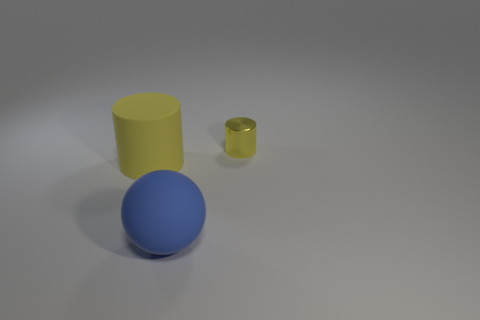Is there any other thing that is the same material as the tiny object?
Give a very brief answer. No. Are there any other things that are the same size as the yellow metal object?
Provide a short and direct response. No. Is the material of the ball the same as the tiny yellow cylinder?
Make the answer very short. No. What shape is the yellow object that is the same size as the blue rubber thing?
Keep it short and to the point. Cylinder. Is the number of small objects greater than the number of big things?
Keep it short and to the point. No. What material is the thing that is on the right side of the large yellow matte cylinder and behind the blue ball?
Your answer should be compact. Metal. What number of other things are made of the same material as the sphere?
Keep it short and to the point. 1. What number of big things have the same color as the sphere?
Your response must be concise. 0. There is a thing on the right side of the thing in front of the yellow cylinder that is in front of the small metal object; what size is it?
Keep it short and to the point. Small. What number of matte objects are green cylinders or large yellow objects?
Your answer should be compact. 1. 